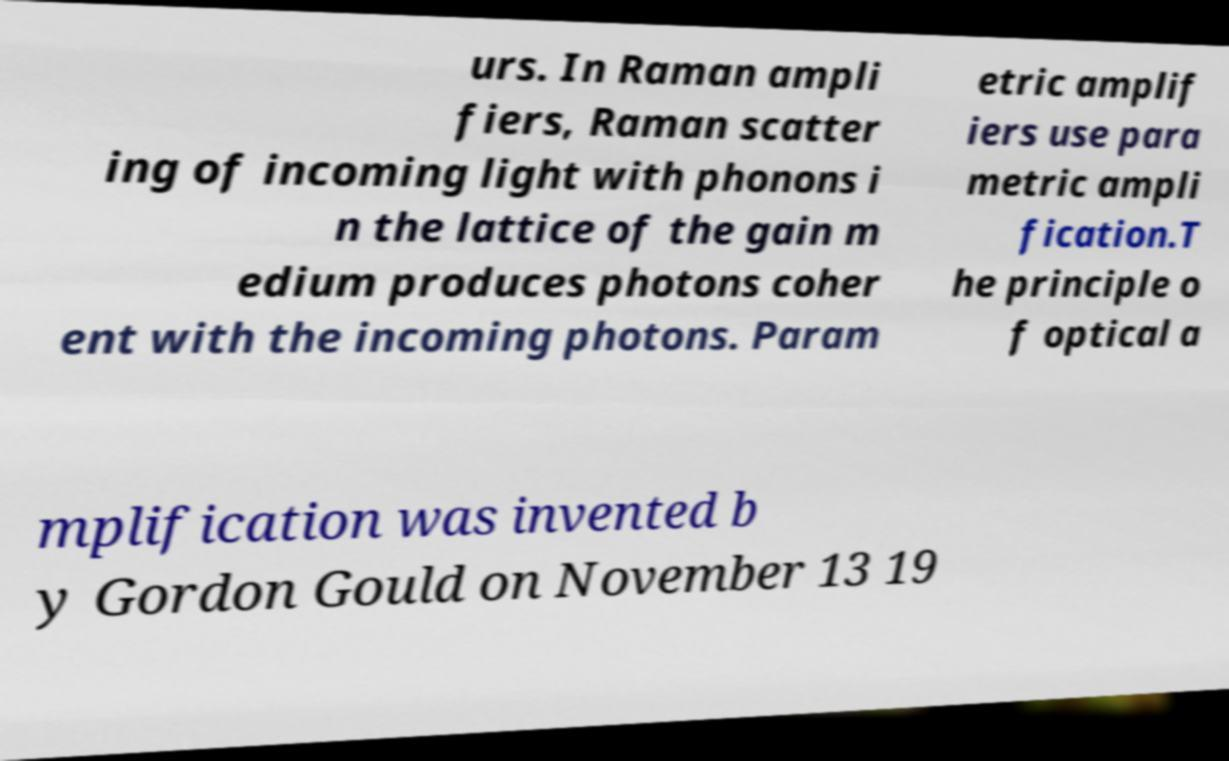Please read and relay the text visible in this image. What does it say? urs. In Raman ampli fiers, Raman scatter ing of incoming light with phonons i n the lattice of the gain m edium produces photons coher ent with the incoming photons. Param etric amplif iers use para metric ampli fication.T he principle o f optical a mplification was invented b y Gordon Gould on November 13 19 